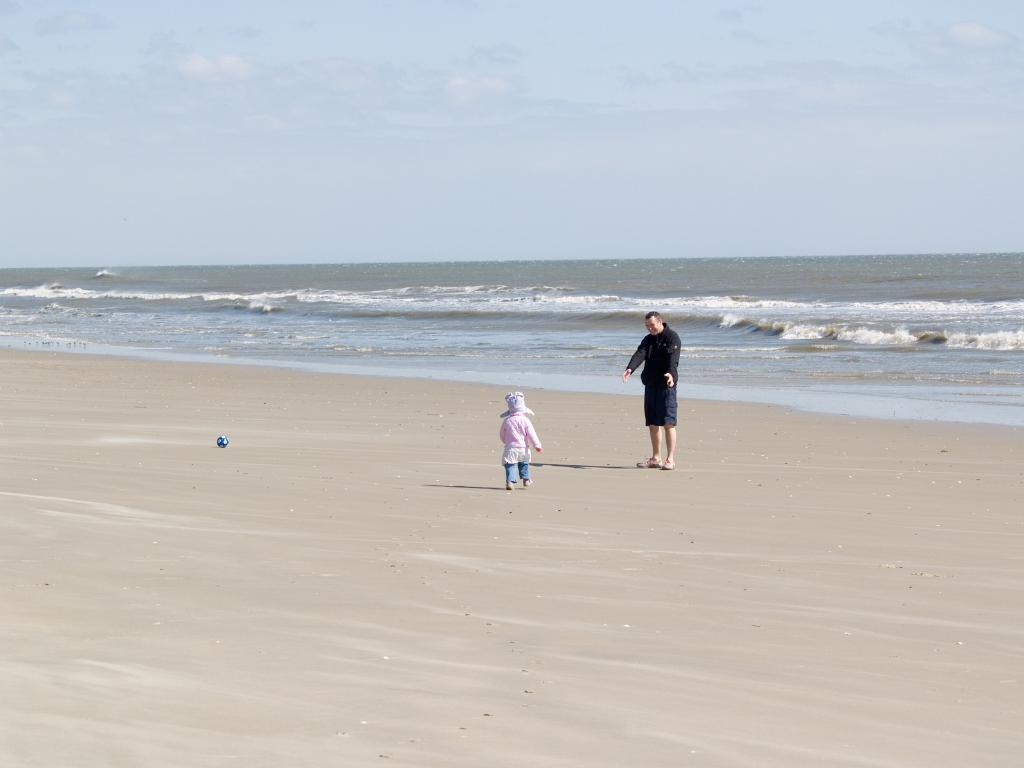What is in the foreground of the image? There is a kid and a man in the foreground of the image. What is the surface they are standing on? Both the kid and the man are on the sand. What object can be seen on the sand? There is a ball on the sand. What can be seen in the background of the image? Water and the sky are visible in the background of the image. What type of magic is the kid performing on the toy in the image? There is no toy present in the image, and the kid is not performing any magic. 